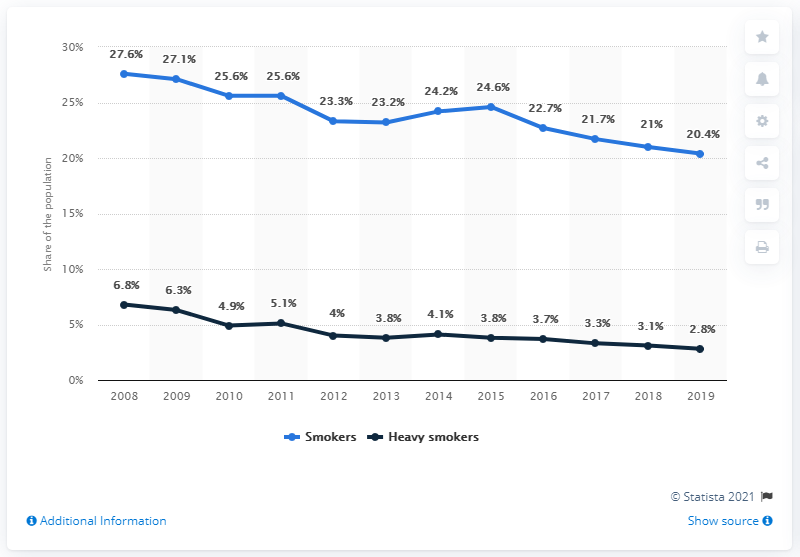Indicate a few pertinent items in this graphic. According to a recent survey, 2.8% of the Dutch population smokes more than 20 cigarettes a day. 